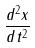<formula> <loc_0><loc_0><loc_500><loc_500>\frac { d ^ { 2 } x } { d t ^ { 2 } }</formula> 